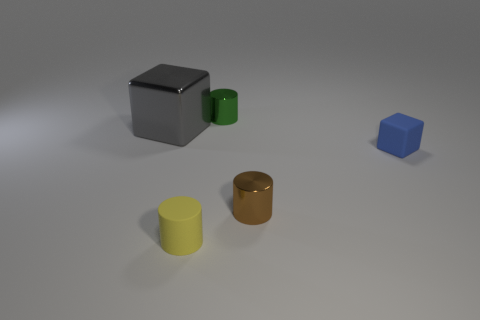Subtract all metallic cylinders. How many cylinders are left? 1 Add 3 tiny cyan metallic spheres. How many objects exist? 8 Subtract all purple cylinders. Subtract all gray blocks. How many cylinders are left? 3 Add 1 green metal objects. How many green metal objects are left? 2 Add 2 metal blocks. How many metal blocks exist? 3 Subtract 0 blue cylinders. How many objects are left? 5 Subtract all blocks. How many objects are left? 3 Subtract all tiny green spheres. Subtract all small yellow cylinders. How many objects are left? 4 